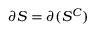<formula> <loc_0><loc_0><loc_500><loc_500>\partial S = \partial ( S ^ { C } )</formula> 